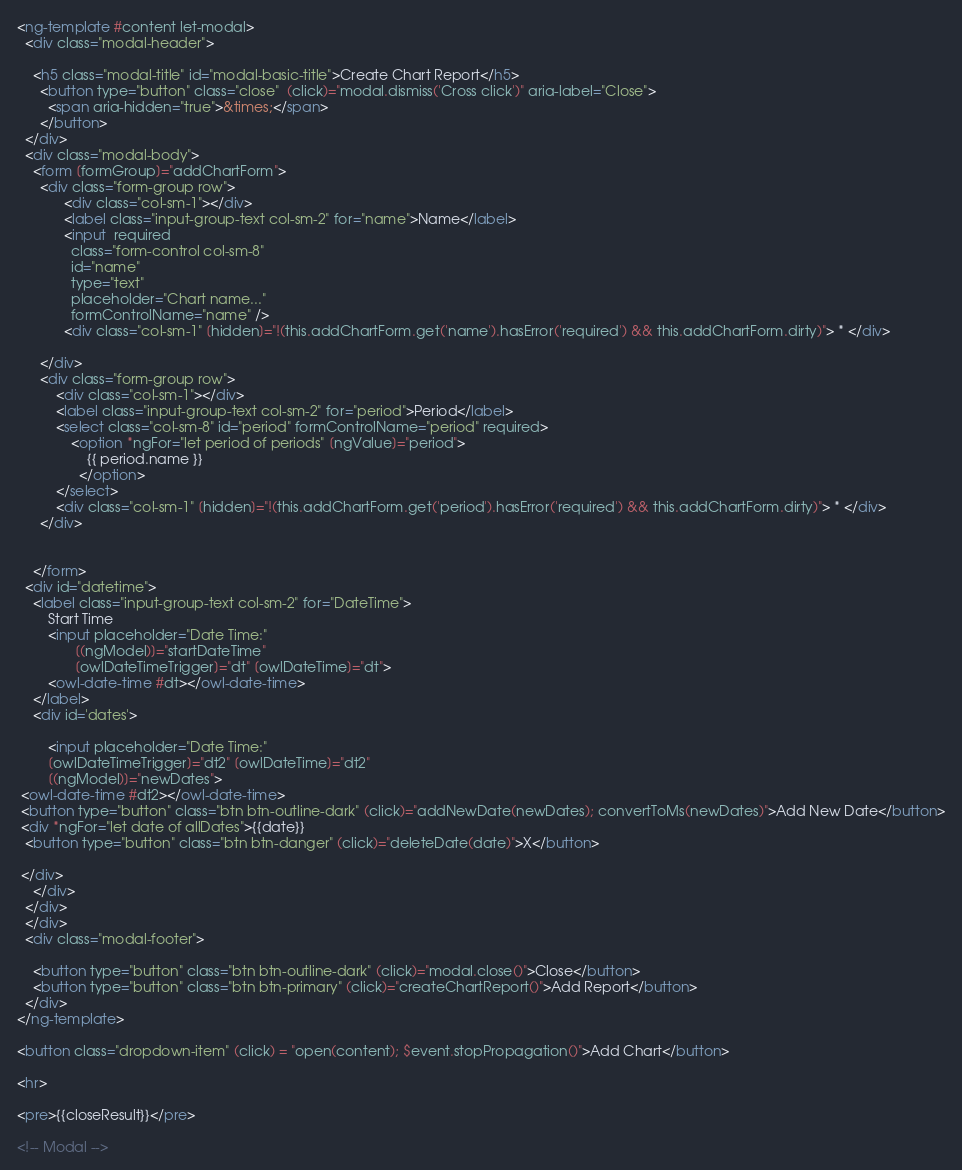<code> <loc_0><loc_0><loc_500><loc_500><_HTML_>

<ng-template #content let-modal>
  <div class="modal-header">

    <h5 class="modal-title" id="modal-basic-title">Create Chart Report</h5>
      <button type="button" class="close"  (click)="modal.dismiss('Cross click')" aria-label="Close">
        <span aria-hidden="true">&times;</span>
      </button>
  </div>
  <div class="modal-body">
    <form [formGroup]="addChartForm">
      <div class="form-group row">
            <div class="col-sm-1"></div>
            <label class="input-group-text col-sm-2" for="name">Name</label>
            <input  required 
              class="form-control col-sm-8" 
              id="name" 
              type="text" 
              placeholder="Chart name..." 
              formControlName="name" />
            <div class="col-sm-1" [hidden]="!(this.addChartForm.get('name').hasError('required') && this.addChartForm.dirty)"> * </div>
          
      </div>
      <div class="form-group row">
          <div class="col-sm-1"></div>
          <label class="input-group-text col-sm-2" for="period">Period</label>
          <select class="col-sm-8" id="period" formControlName="period" required>
              <option *ngFor="let period of periods" [ngValue]="period">
                  {{ period.name }}
                </option>
          </select>
          <div class="col-sm-1" [hidden]="!(this.addChartForm.get('period').hasError('required') && this.addChartForm.dirty)"> * </div>
      </div>
      
      
    </form>
  <div id="datetime">
    <label class="input-group-text col-sm-2" for="DateTime">
        Start Time
        <input placeholder="Date Time:"
               [(ngModel)]="startDateTime"
               [owlDateTimeTrigger]="dt" [owlDateTime]="dt">
        <owl-date-time #dt></owl-date-time>
    </label>
    <div id='dates'>
      
        <input placeholder="Date Time:"
        [owlDateTimeTrigger]="dt2" [owlDateTime]="dt2"
        [(ngModel)]="newDates">
 <owl-date-time #dt2></owl-date-time>
 <button type="button" class="btn btn-outline-dark" (click)="addNewDate(newDates); convertToMs(newDates)">Add New Date</button>
 <div *ngFor="let date of allDates">{{date}} 
  <button type="button" class="btn btn-danger" (click)="deleteDate(date)">X</button>
   
 </div>
    </div>
  </div>
  </div>
  <div class="modal-footer">
    
    <button type="button" class="btn btn-outline-dark" (click)="modal.close()">Close</button>
    <button type="button" class="btn btn-primary" (click)="createChartReport()">Add Report</button>
  </div>
</ng-template>

<button class="dropdown-item" (click) = "open(content); $event.stopPropagation()">Add Chart</button>

<hr>

<pre>{{closeResult}}</pre>

<!-- Modal -->
</code> 